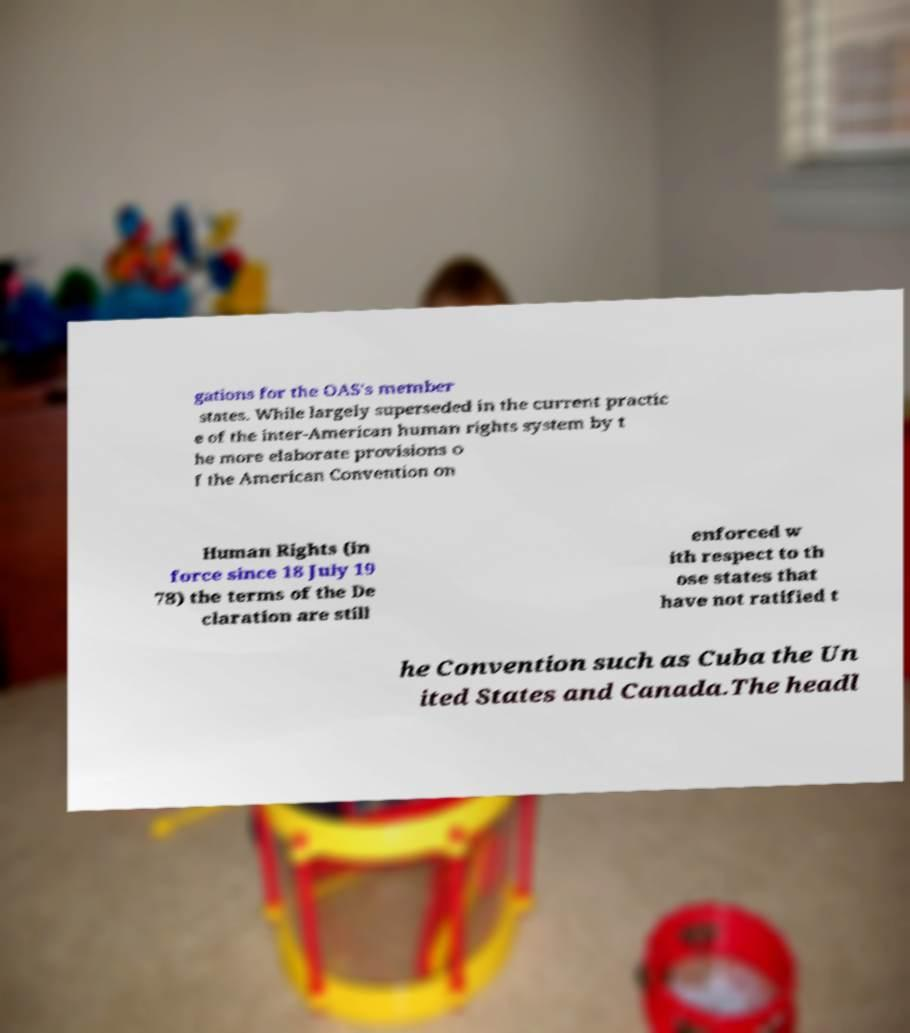I need the written content from this picture converted into text. Can you do that? gations for the OAS's member states. While largely superseded in the current practic e of the inter-American human rights system by t he more elaborate provisions o f the American Convention on Human Rights (in force since 18 July 19 78) the terms of the De claration are still enforced w ith respect to th ose states that have not ratified t he Convention such as Cuba the Un ited States and Canada.The headl 